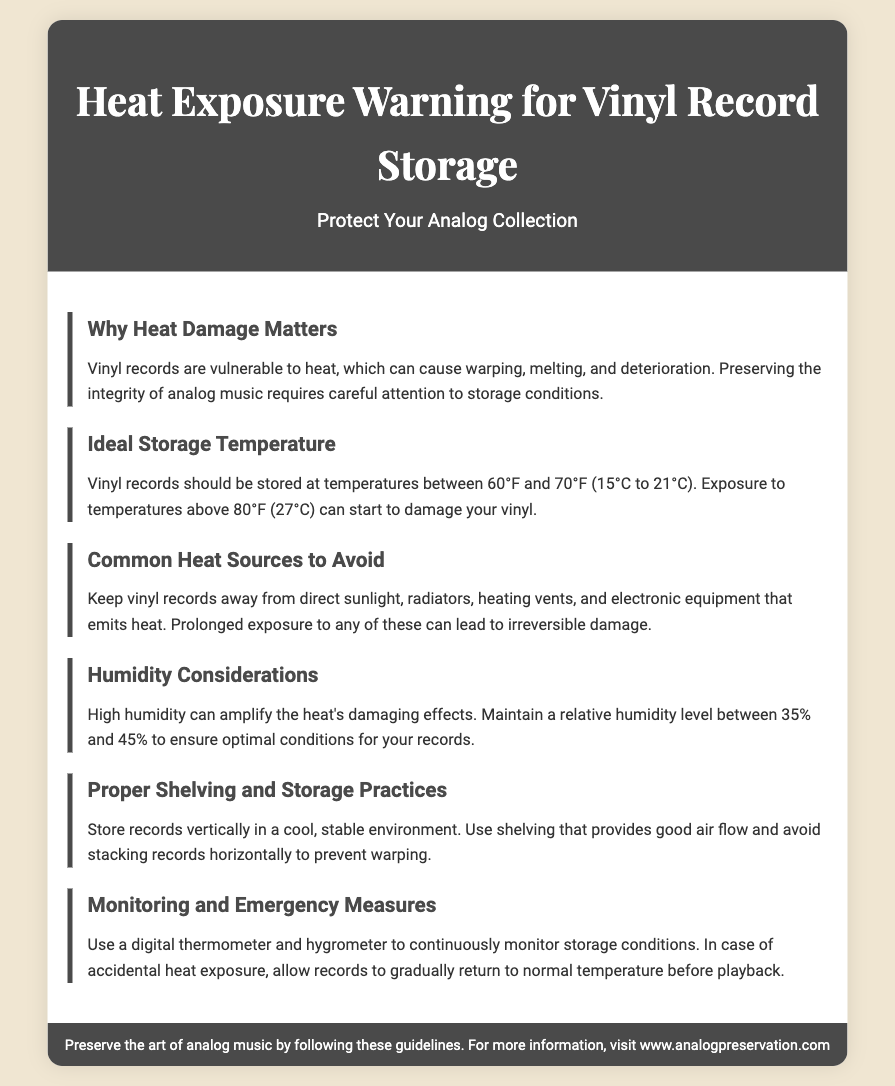What is the ideal storage temperature for vinyl records? The ideal storage temperature is stated as the range of temperatures that are recommended for vinyl record storage.
Answer: 60°F to 70°F What can high humidity do to vinyl records? The document mentions that high humidity can amplify the damaging effects of heat, impacting the preservation of vinyl records.
Answer: Amplify heat's damaging effects What is a common heat source to avoid? The section on common heat sources lists various potential sources of heat that can damage vinyl records.
Answer: Direct sunlight What is the recommended relative humidity level for vinyl records? The document specifies the range of humidity levels that should be maintained for optimal storage of vinyl records.
Answer: 35% to 45% What should you use to monitor storage conditions? The document suggests a tool that is essential for keeping track of the environment where vinyl records are stored.
Answer: Digital thermometer and hygrometer What can happen to vinyl records at temperatures above 80°F? The document describes the threshold temperature above which damage to vinyl records can begin to occur.
Answer: Start to damage How should vinyl records be stored? The section on proper shelving and storage practices provides guidance on the orientation for storing records to prevent damage.
Answer: Vertically 